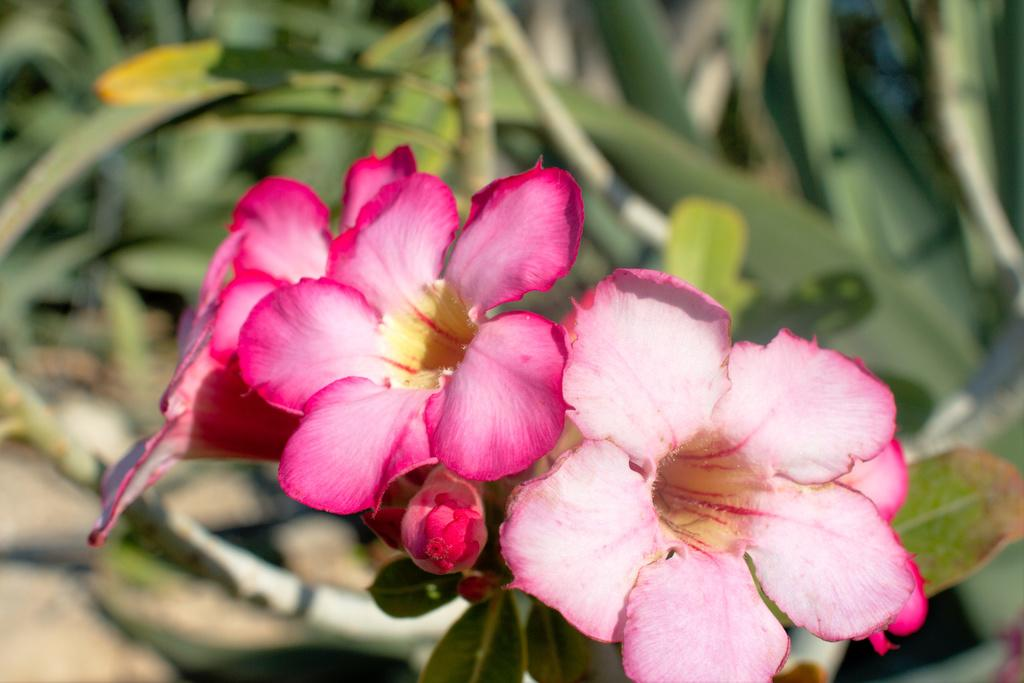What type of plant is in the image? There is a plant with flowers in the image. What color are the flowers on the plant? The flowers are pink. What can be seen in the background of the image? There are trees visible in the background of the image. How many legs can be seen on the plant in the image? Plants do not have legs, so this question cannot be answered. 